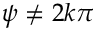<formula> <loc_0><loc_0><loc_500><loc_500>\psi \neq 2 k \pi</formula> 